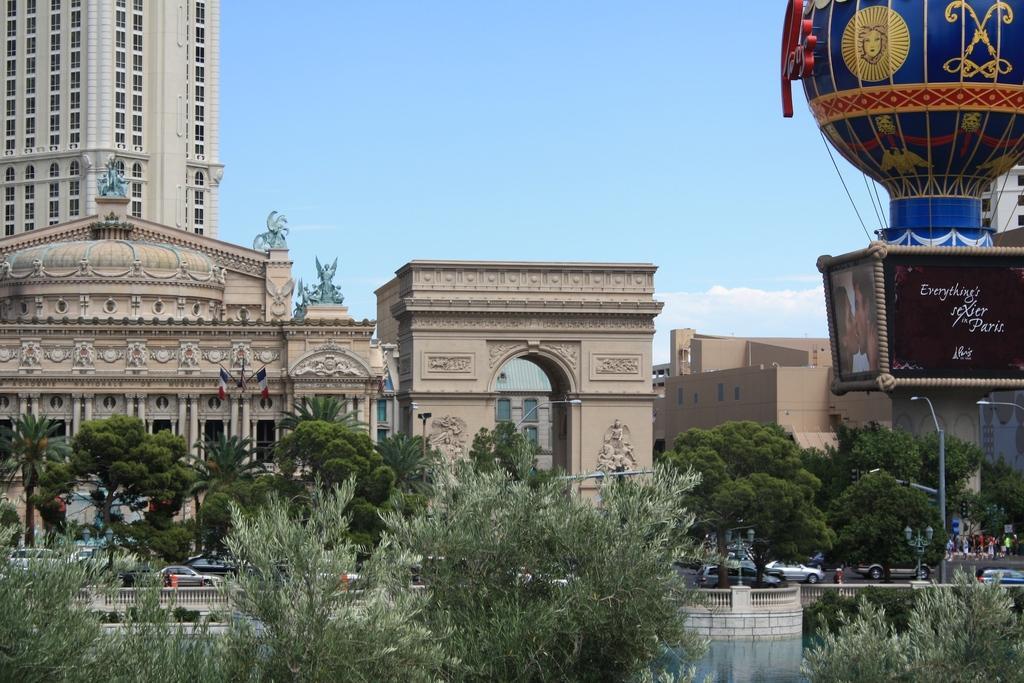Can you describe this image briefly? In the center of the image there is an arch. On the left there are buildings. At the bottom there are trees, poles and cars. We can see a fence. At the top there is sky. 